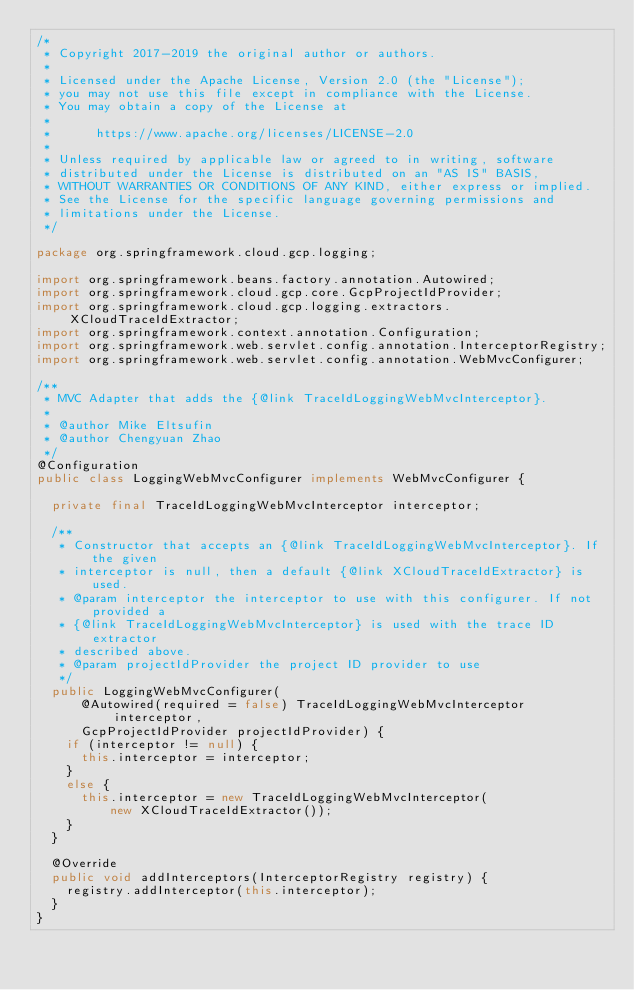Convert code to text. <code><loc_0><loc_0><loc_500><loc_500><_Java_>/*
 * Copyright 2017-2019 the original author or authors.
 *
 * Licensed under the Apache License, Version 2.0 (the "License");
 * you may not use this file except in compliance with the License.
 * You may obtain a copy of the License at
 *
 *      https://www.apache.org/licenses/LICENSE-2.0
 *
 * Unless required by applicable law or agreed to in writing, software
 * distributed under the License is distributed on an "AS IS" BASIS,
 * WITHOUT WARRANTIES OR CONDITIONS OF ANY KIND, either express or implied.
 * See the License for the specific language governing permissions and
 * limitations under the License.
 */

package org.springframework.cloud.gcp.logging;

import org.springframework.beans.factory.annotation.Autowired;
import org.springframework.cloud.gcp.core.GcpProjectIdProvider;
import org.springframework.cloud.gcp.logging.extractors.XCloudTraceIdExtractor;
import org.springframework.context.annotation.Configuration;
import org.springframework.web.servlet.config.annotation.InterceptorRegistry;
import org.springframework.web.servlet.config.annotation.WebMvcConfigurer;

/**
 * MVC Adapter that adds the {@link TraceIdLoggingWebMvcInterceptor}.
 *
 * @author Mike Eltsufin
 * @author Chengyuan Zhao
 */
@Configuration
public class LoggingWebMvcConfigurer implements WebMvcConfigurer {

	private final TraceIdLoggingWebMvcInterceptor interceptor;

	/**
	 * Constructor that accepts an {@link TraceIdLoggingWebMvcInterceptor}. If the given
	 * interceptor is null, then a default {@link XCloudTraceIdExtractor} is used.
	 * @param interceptor the interceptor to use with this configurer. If not provided a
	 * {@link TraceIdLoggingWebMvcInterceptor} is used with the trace ID extractor
	 * described above.
	 * @param projectIdProvider the project ID provider to use
	 */
	public LoggingWebMvcConfigurer(
			@Autowired(required = false) TraceIdLoggingWebMvcInterceptor interceptor,
			GcpProjectIdProvider projectIdProvider) {
		if (interceptor != null) {
			this.interceptor = interceptor;
		}
		else {
			this.interceptor = new TraceIdLoggingWebMvcInterceptor(
					new XCloudTraceIdExtractor());
		}
	}

	@Override
	public void addInterceptors(InterceptorRegistry registry) {
		registry.addInterceptor(this.interceptor);
	}
}
</code> 